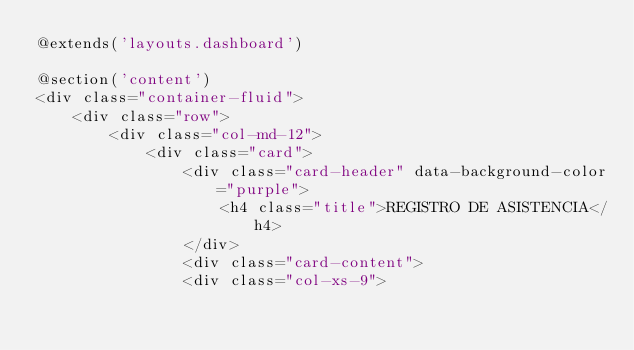Convert code to text. <code><loc_0><loc_0><loc_500><loc_500><_PHP_>@extends('layouts.dashboard')

@section('content')
<div class="container-fluid">
    <div class="row">
        <div class="col-md-12">
            <div class="card">
                <div class="card-header" data-background-color="purple">
                    <h4 class="title">REGISTRO DE ASISTENCIA</h4>
                </div>
                <div class="card-content">
                <div class="col-xs-9"></code> 